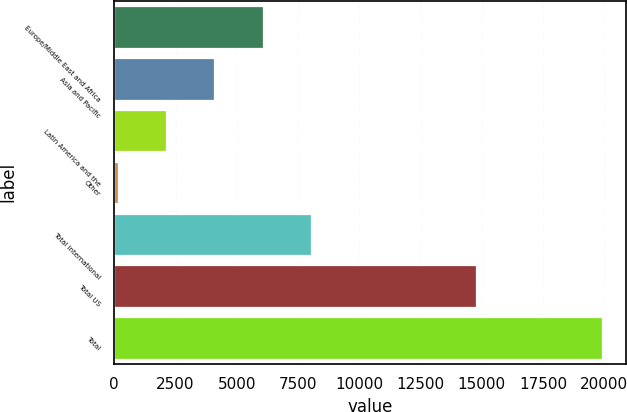Convert chart to OTSL. <chart><loc_0><loc_0><loc_500><loc_500><bar_chart><fcel>Europe/Middle East and Africa<fcel>Asia and Pacific<fcel>Latin America and the<fcel>Other<fcel>Total international<fcel>Total US<fcel>Total<nl><fcel>6064.5<fcel>4090<fcel>2115.5<fcel>141<fcel>8039<fcel>14774<fcel>19886<nl></chart> 